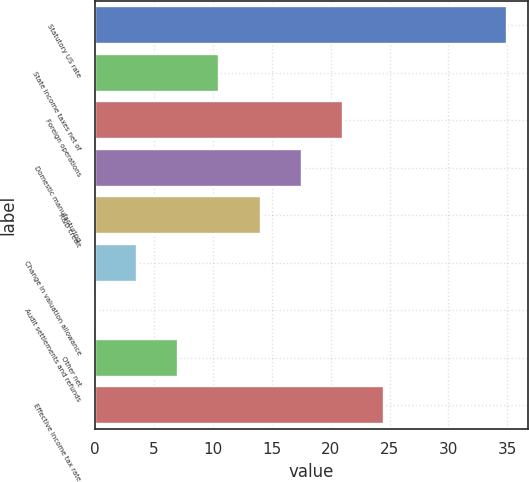Convert chart to OTSL. <chart><loc_0><loc_0><loc_500><loc_500><bar_chart><fcel>Statutory US rate<fcel>State income taxes net of<fcel>Foreign operations<fcel>Domestic manufacturing<fcel>R&D credit<fcel>Change in valuation allowance<fcel>Audit settlements and refunds<fcel>Other net<fcel>Effective income tax rate<nl><fcel>35<fcel>10.57<fcel>21.04<fcel>17.55<fcel>14.06<fcel>3.59<fcel>0.1<fcel>7.08<fcel>24.53<nl></chart> 